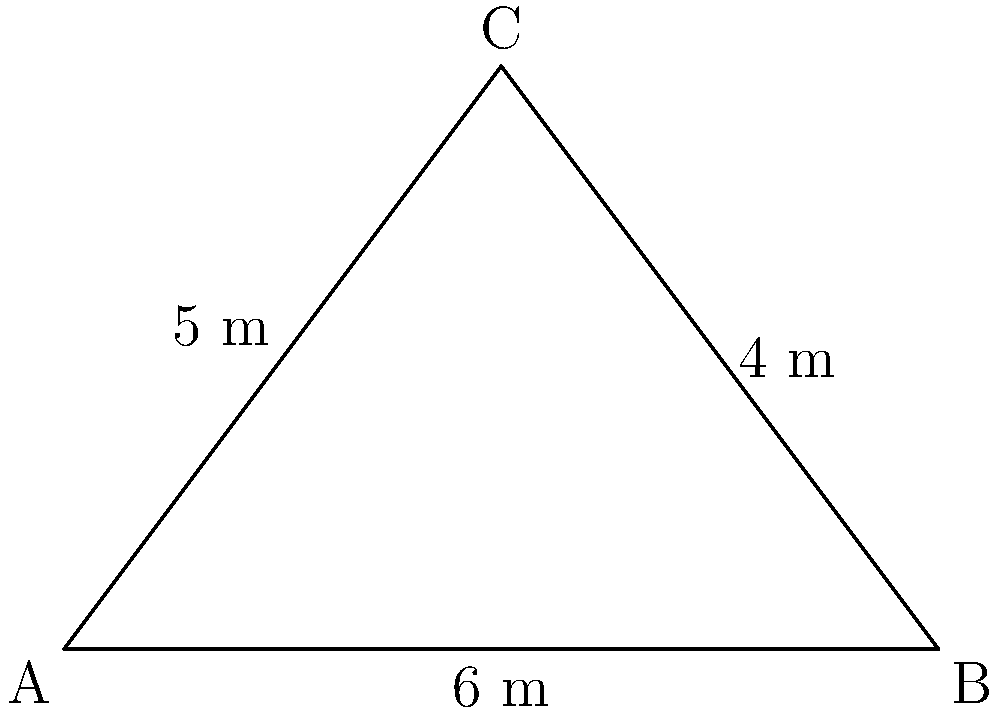Ahoy, matey! Ye've got a triangular sail with the following measurements: the base is 6 meters, the height is 4 meters, and one of the sides is 5 meters. What be the area of this sail in square meters? To find the area of the triangular sail, we'll use the formula for the area of a triangle:

$$A = \frac{1}{2} \times base \times height$$

We're given:
- Base = 6 meters
- Height = 4 meters

Let's plug these values into our formula:

$$A = \frac{1}{2} \times 6 \times 4$$

$$A = \frac{1}{2} \times 24$$

$$A = 12$$

Therefore, the area of the triangular sail is 12 square meters.

Note: The 5-meter side measurement isn't needed for this calculation, but it's useful for confirming the triangle's shape.
Answer: 12 m² 